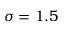Convert formula to latex. <formula><loc_0><loc_0><loc_500><loc_500>\sigma = 1 . 5</formula> 